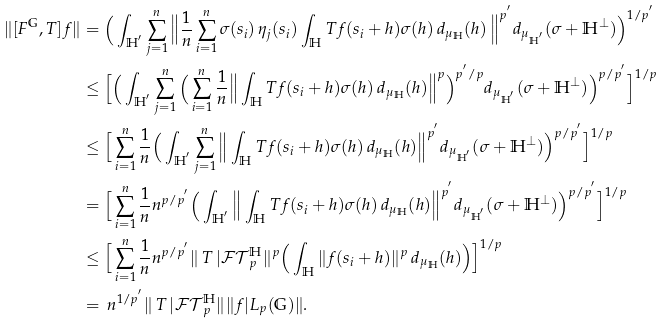Convert formula to latex. <formula><loc_0><loc_0><loc_500><loc_500>\| [ F ^ { \mathbb { G } } , T ] f \| & = \Big { ( } \int _ { \mathbb { H } ^ { ^ { \prime } } } \sum _ { j = 1 } ^ { n } \Big { \| } \frac { 1 } { n } \sum _ { i = 1 } ^ { n } \sigma ( s _ { i } ) \, \eta _ { j } ( s _ { i } ) \int _ { \mathbb { H } } T f ( s _ { i } + h ) \sigma ( h ) \, d _ { \mu _ { \mathbb { H } } } ( h ) \, \Big { \| } ^ { p ^ { ^ { \prime } } } d _ { { \mu } _ { \mathbb { H } ^ { ^ { \prime } } } } ( \sigma + \mathbb { H } ^ { \bot } ) \Big { ) } ^ { 1 / { p ^ { ^ { \prime } } } } \\ & \leq \Big { [ } \Big { ( } \int _ { \mathbb { H } ^ { ^ { \prime } } } \sum _ { j = 1 } ^ { n } \Big { ( } \sum _ { i = 1 } ^ { n } \frac { 1 } { n } \Big { \| } \int _ { \mathbb { H } } T f ( s _ { i } + h ) \sigma ( h ) \, d _ { \mu _ { \mathbb { H } } } ( h ) \Big { \| } ^ { p } \Big { ) } ^ { { p ^ { ^ { \prime } } } / { p } } d _ { { \mu } _ { \mathbb { H } ^ { ^ { \prime } } } } ( \sigma + \mathbb { H } ^ { \bot } ) \Big { ) } ^ { p / { p ^ { ^ { \prime } } } } \Big { ] } ^ { 1 / p } \\ & \leq \Big { [ } \sum _ { i = 1 } ^ { n } \frac { 1 } { n } \Big { ( } \int _ { \mathbb { H } ^ { ^ { \prime } } } \sum _ { j = 1 } ^ { n } \Big { \| } \int _ { \mathbb { H } } T f ( s _ { i } + h ) \sigma ( h ) \, d _ { \mu _ { \mathbb { H } } } ( h ) \Big { \| } ^ { p ^ { ^ { \prime } } } d _ { { \mu } _ { \mathbb { H } ^ { ^ { \prime } } } } ( \sigma + \mathbb { H } ^ { \bot } ) \Big { ) } ^ { p / { p ^ { ^ { \prime } } } } \Big { ] } ^ { 1 / p } \\ & = \Big { [ } \sum _ { i = 1 } ^ { n } \frac { 1 } { n } n ^ { p / { p ^ { ^ { \prime } } } } \Big { ( } \int _ { \mathbb { H } ^ { ^ { \prime } } } \Big { \| } \int _ { \mathbb { H } } T f ( s _ { i } + h ) \sigma ( h ) \, d _ { \mu _ { \mathbb { H } } } ( h ) \Big { \| } ^ { p ^ { ^ { \prime } } } d _ { { \mu } _ { \mathbb { H } ^ { ^ { \prime } } } } ( \sigma + \mathbb { H } ^ { \bot } ) \Big { ) } ^ { p / { p ^ { ^ { \prime } } } } \Big { ] } ^ { 1 / p } \\ & \leq \Big { [ } \sum _ { i = 1 } ^ { n } \frac { 1 } { n } n ^ { p / { p ^ { ^ { \prime } } } } \| \, T \, | \mathcal { F T } _ { p } ^ { \mathbb { H } } \| ^ { p } \Big { ( } \int _ { \mathbb { H } } \| f ( s _ { i } + h ) \| ^ { p } \, d _ { \mu _ { \mathbb { H } } } ( h ) \Big { ) } \Big { ] } ^ { 1 / p } \\ & = \, n ^ { 1 / { p ^ { ^ { \prime } } } } \| \, T \, | \mathcal { F T } _ { p } ^ { \mathbb { H } } \| \| f | L _ { p } ( \mathbb { G } ) \| . \\</formula> 